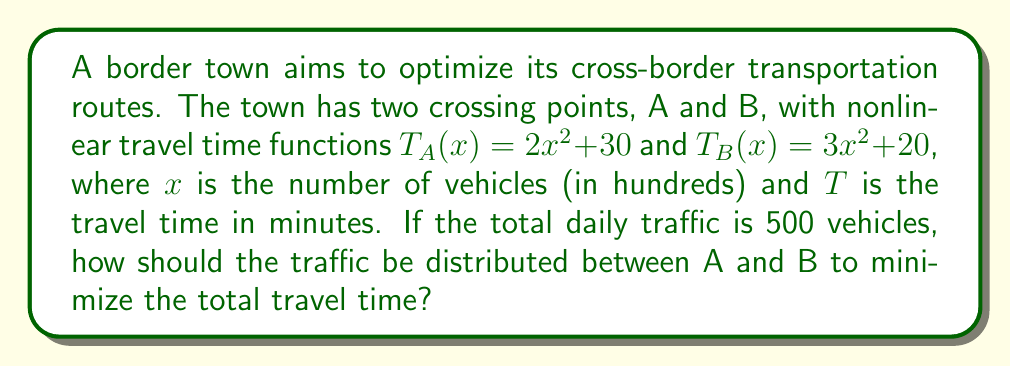Can you answer this question? 1) Let $x$ be the number of vehicles (in hundreds) using crossing point A. Then, $(5-x)$ will be using point B.

2) The total travel time function is:
   $$T(x) = T_A(x) + T_B(5-x) = (2x^2 + 30) + (3(5-x)^2 + 20)$$

3) Expand the equation:
   $$T(x) = 2x^2 + 30 + 3(25 - 10x + x^2) + 20$$
   $$T(x) = 2x^2 + 30 + 75 - 30x + 3x^2 + 20$$
   $$T(x) = 5x^2 - 30x + 125$$

4) To minimize T(x), find where $\frac{dT}{dx} = 0$:
   $$\frac{dT}{dx} = 10x - 30 = 0$$
   $$10x = 30$$
   $$x = 3$$

5) Verify it's a minimum by checking the second derivative:
   $$\frac{d^2T}{dx^2} = 10 > 0$$, confirming a minimum.

6) Therefore, 300 vehicles should use crossing A, and 200 should use B.

7) Calculate the minimum total travel time:
   $$T(3) = 5(3^2) - 30(3) + 125 = 45 - 90 + 125 = 80$$

The minimum total travel time is 80 minutes.
Answer: 300 vehicles at crossing A, 200 at B; minimum total travel time: 80 minutes 